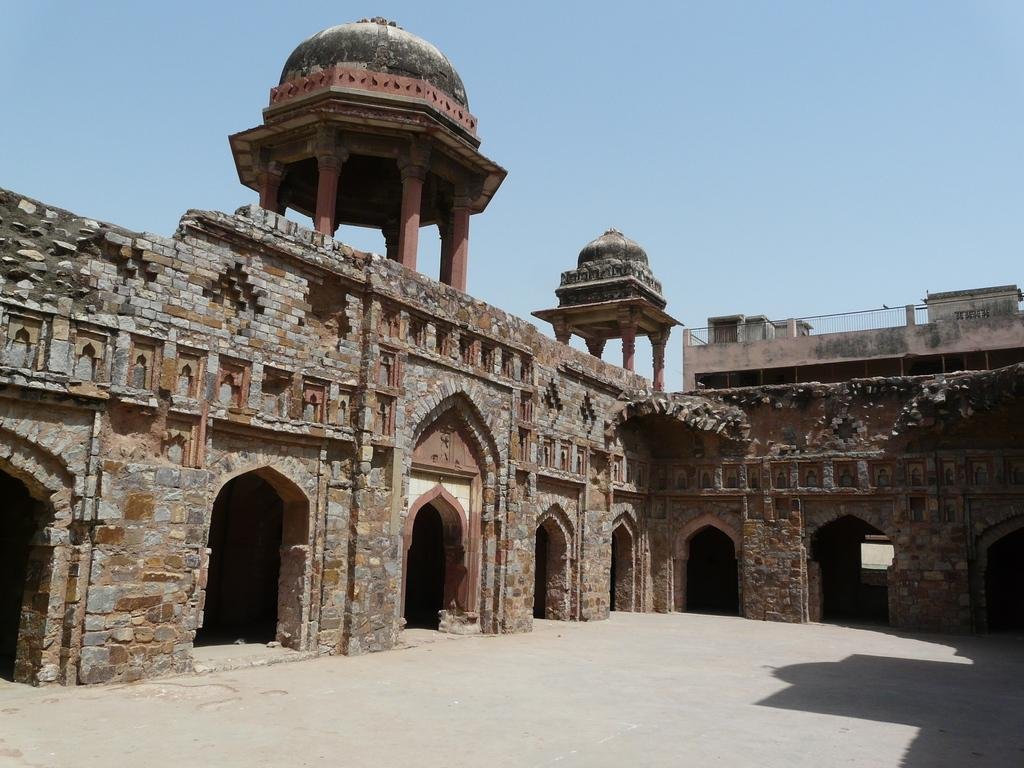What type of structure is present in the image? There is a fort in the image. What can be seen in the background of the image? The sky is visible in the background of the image. What type of sidewalk can be seen near the fort in the image? There is no sidewalk present in the image; it only features a fort and the sky in the background. What is the smile of the fort in the image? The fort does not have a smile, as it is an inanimate object. 